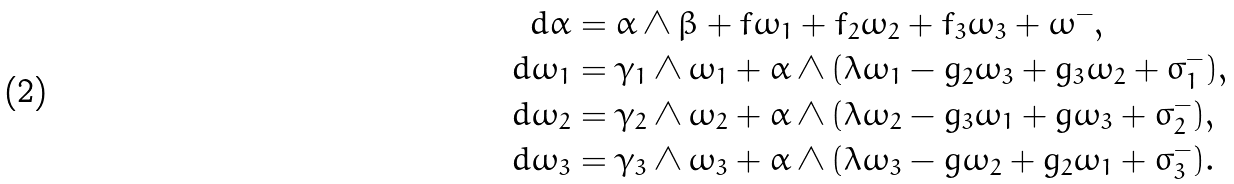Convert formula to latex. <formula><loc_0><loc_0><loc_500><loc_500>d \alpha & = \alpha \wedge \beta + f \omega _ { 1 } + f _ { 2 } \omega _ { 2 } + f _ { 3 } \omega _ { 3 } + \omega ^ { - } , \\ d \omega _ { 1 } & = \gamma _ { 1 } \wedge \omega _ { 1 } + \alpha \wedge ( \lambda \omega _ { 1 } - g _ { 2 } \omega _ { 3 } + g _ { 3 } \omega _ { 2 } + \sigma _ { 1 } ^ { - } ) , \\ d \omega _ { 2 } & = \gamma _ { 2 } \wedge \omega _ { 2 } + \alpha \wedge ( \lambda \omega _ { 2 } - g _ { 3 } \omega _ { 1 } + g \omega _ { 3 } + \sigma _ { 2 } ^ { - } ) , \\ d \omega _ { 3 } & = \gamma _ { 3 } \wedge \omega _ { 3 } + \alpha \wedge ( \lambda \omega _ { 3 } - g \omega _ { 2 } + g _ { 2 } \omega _ { 1 } + \sigma _ { 3 } ^ { - } ) .</formula> 